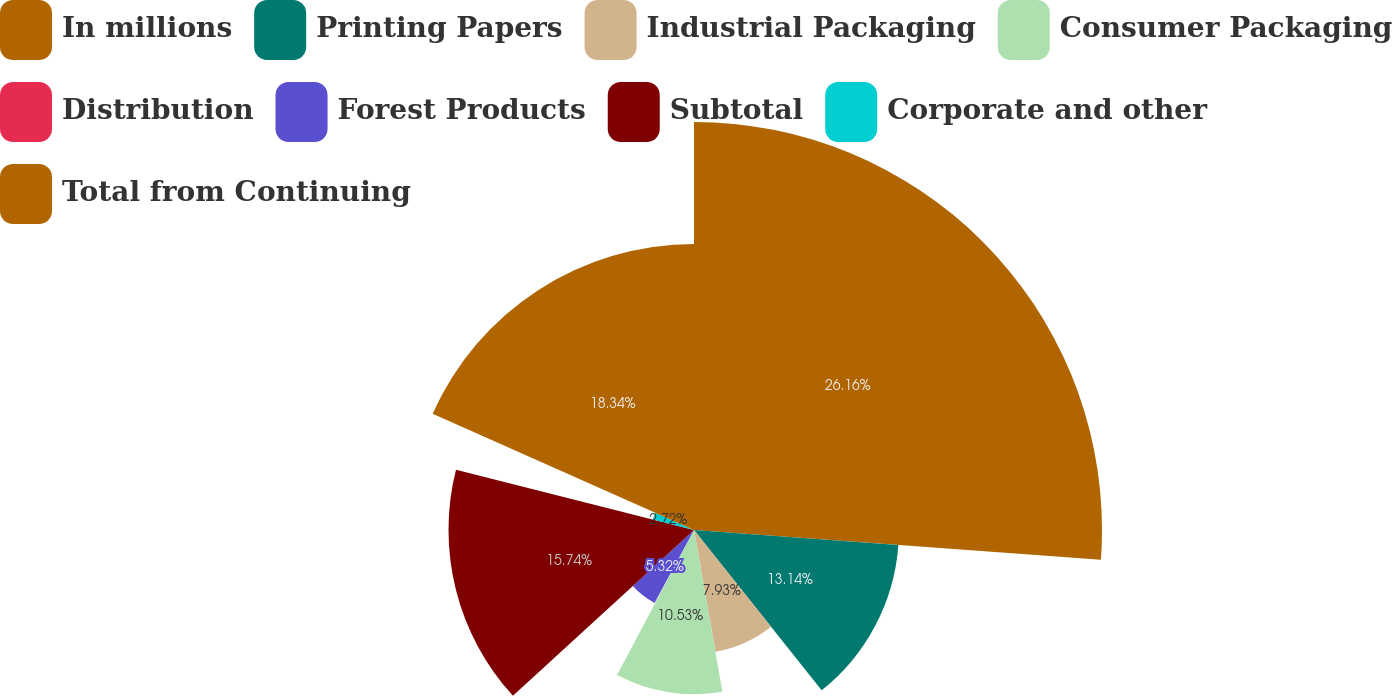<chart> <loc_0><loc_0><loc_500><loc_500><pie_chart><fcel>In millions<fcel>Printing Papers<fcel>Industrial Packaging<fcel>Consumer Packaging<fcel>Distribution<fcel>Forest Products<fcel>Subtotal<fcel>Corporate and other<fcel>Total from Continuing<nl><fcel>26.16%<fcel>13.14%<fcel>7.93%<fcel>10.53%<fcel>0.12%<fcel>5.32%<fcel>15.74%<fcel>2.72%<fcel>18.34%<nl></chart> 